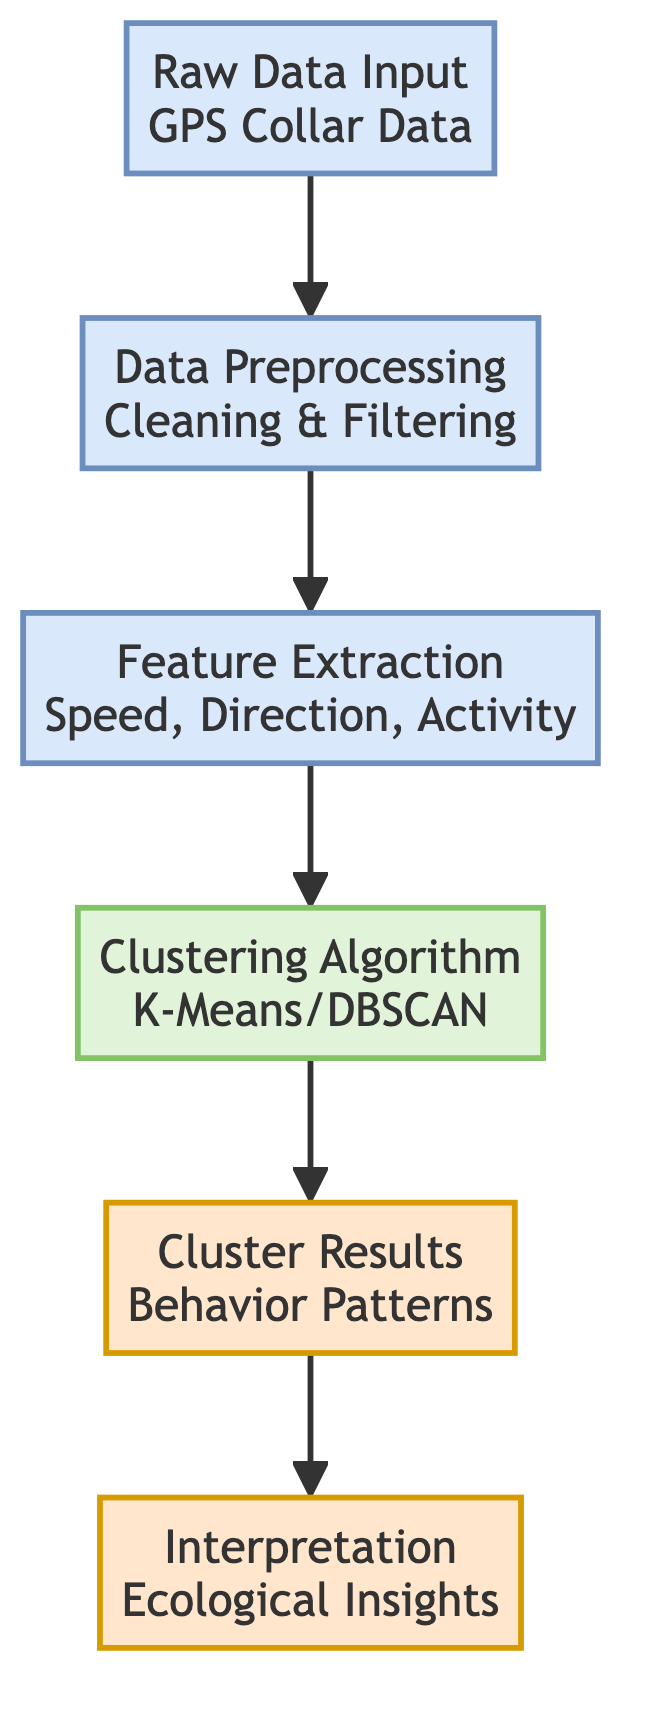What is the input node in this diagram? The diagram starts with the "Raw Data Input" node, which represents the initial data before any processing occurs. This node specifically highlights that it consists of GPS collar data for small mammals.
Answer: Raw Data Input Which algorithm is used in the clustering process? The diagram specifies two clustering algorithms: K-Means and DBSCAN, indicating the methods available to analyze the behavior patterns of the small mammals based on extracted features.
Answer: K-Means/DBSCAN How many nodes are classified as data nodes? There are four nodes categorized as data nodes, which include "Raw Data Input," "Data Preprocessing," "Feature Extraction," and "Cluster Results."
Answer: Four What follows the feature extraction step in the diagram? After "Feature Extraction," the next step in the flow is the "Clustering Algorithm," indicating the process of applying clustering techniques to the extracted features.
Answer: Clustering Algorithm What is the final step of the analysis according to the diagram? The last process depicted in the diagram is "Interpretation," which focuses on deriving ecological insights from the results of clustering behavior patterns.
Answer: Interpretation How does the "Clustering Algorithm" relate to "Cluster Results"? The "Clustering Algorithm" directly feeds into the "Cluster Results," meaning that the output from the clustering analysis leads to insights about different behavior patterns categorized as clusters.
Answer: Directly feeds into What type of data is processed in the diagram? The diagram specifies that GPS collar data is the primary data type being processed through various steps to analyze small mammal behavior patterns.
Answer: GPS Collar Data What is extracted from the raw data during the feature extraction step? The feature extraction step focuses on retrieving attributes such as speed, direction, and activity from the raw GPS data, which are essential for clustering.
Answer: Speed, Direction, Activity 